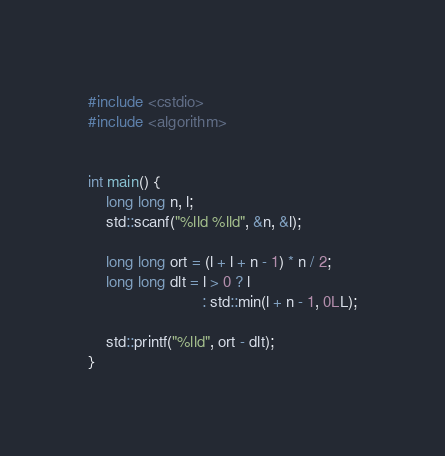<code> <loc_0><loc_0><loc_500><loc_500><_C++_>#include <cstdio>
#include <algorithm>


int main() {
    long long n, l;
    std::scanf("%lld %lld", &n, &l);

    long long ort = (l + l + n - 1) * n / 2;
    long long dlt = l > 0 ? l
                          : std::min(l + n - 1, 0LL);

    std::printf("%lld", ort - dlt);
}</code> 